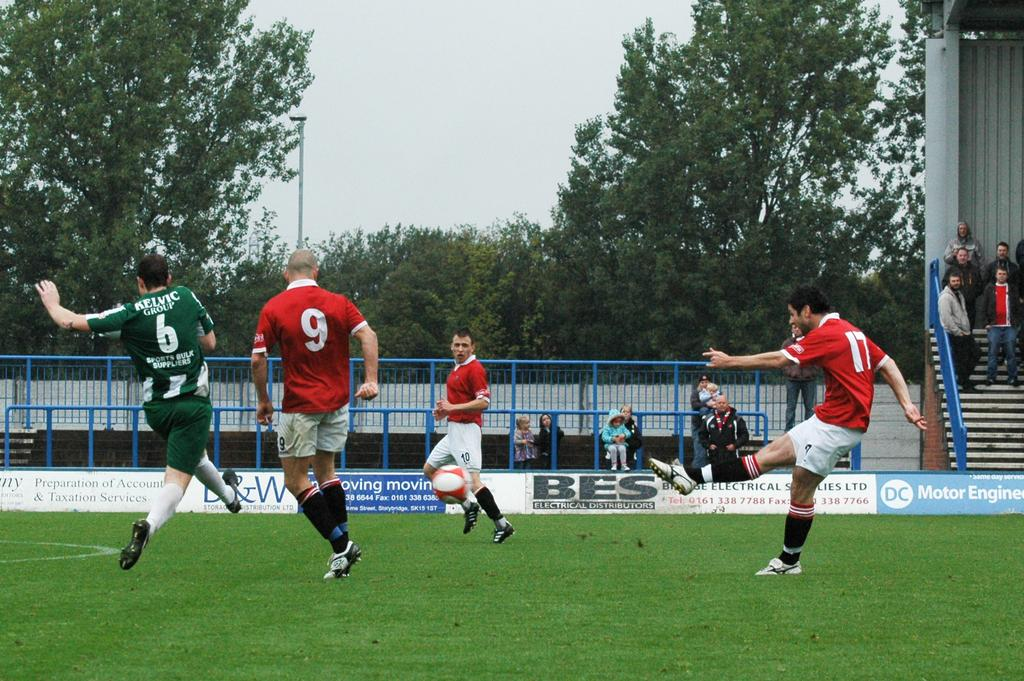<image>
Give a short and clear explanation of the subsequent image. Soccer players with a player number 6 next to number 9. 